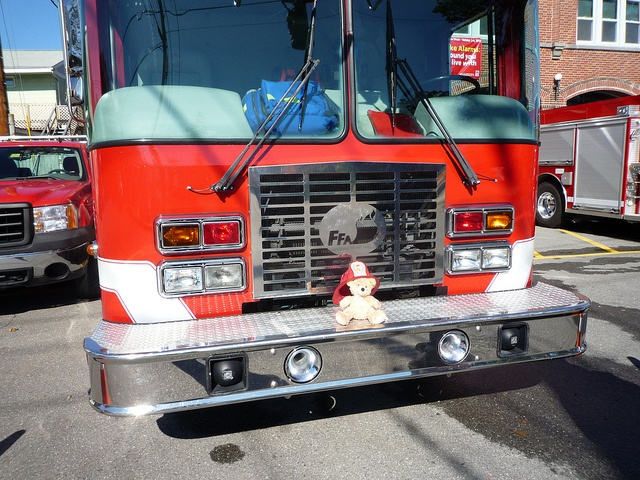Describe the objects in this image and their specific colors. I can see truck in gray, black, darkgray, and white tones, truck in gray, black, darkgray, and brown tones, truck in gray, darkgray, maroon, and lightgray tones, backpack in gray and blue tones, and teddy bear in gray, ivory, tan, and darkgray tones in this image. 